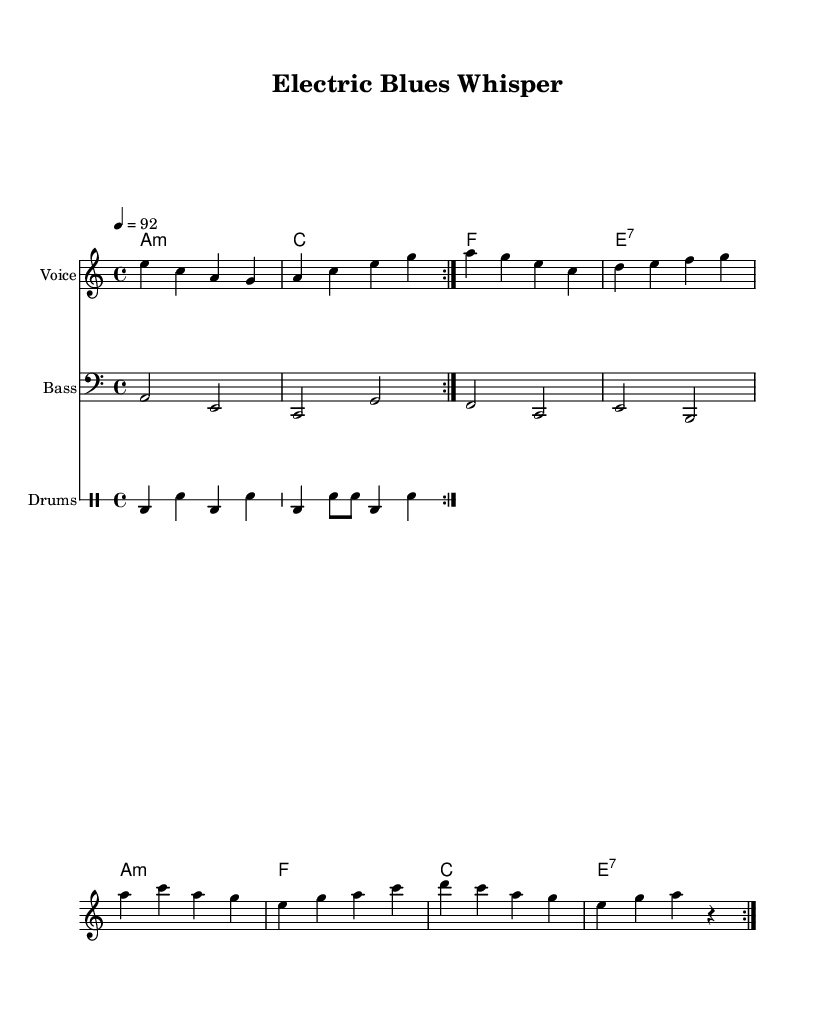What is the key signature of this music? The key signature is A minor, which has no sharps or flats.
Answer: A minor What is the time signature of this music? The time signature is indicated as 4/4, meaning there are four beats per measure.
Answer: 4/4 What is the tempo marking for this piece? The tempo marking is set at a quarter note equals 92 beats per minute.
Answer: 92 How many measures are there in the melody section? The melody is repeated twice, and since one cycle contains eight measures, there are a total of 16 measures in this section.
Answer: 16 What type of bass clef is used in this piece? The bass is written in the bass clef, which is typically used for lower range instruments and voices.
Answer: Bass clef What vocal techniques could enhance this experimental blues piece? Given the electronic elements, techniques like pitch modulation, harmonizing, or vocal filters might be used to intertwine with the instrumental background.
Answer: Pitch modulation How does the drum pattern contribute to the blues feel in this music? The drum pattern contains a mix of bass drums and snare hits in a syncopated rhythm, which adds to the groove characteristic of blues music.
Answer: Syncopation 